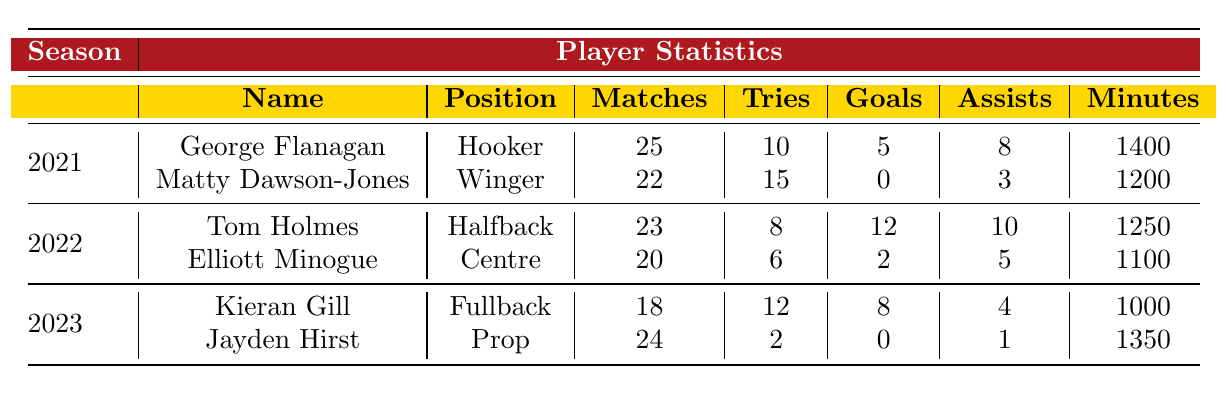What is the total number of tries scored by George Flanagan in the 2021 season? George Flanagan scored 10 tries in the 2021 season, as indicated in the table under his player's statistics.
Answer: 10 How many goals did Matty Dawson-Jones score in the 2021 season? The table shows that Matty Dawson-Jones scored 0 goals during the 2021 season.
Answer: 0 In which season did Tom Holmes have the highest number of assists? The table indicates that Tom Holmes recorded 10 assists in the 2022 season, which is higher than the assists of other players listed.
Answer: 2022 What is the average number of matches played by players in the 2023 season? Kieran Gill played 18 matches and Jayden Hirst played 24 matches in 2023. The average is calculated as (18 + 24) / 2 = 21.
Answer: 21 Which player played the most minutes in the 2021 season? Based on the table, George Flanagan played 1400 minutes, which is more than Matty Dawson-Jones's 1200 minutes, making him the player with the most minutes in 2021.
Answer: George Flanagan Did Elliott Minogue score more tries than Kieran Gill in their respective seasons? Elliott Minogue scored 6 tries in 2022 while Kieran Gill scored 12 tries in 2023. Since 12 is greater than 6, Kieran Gill scored more tries than Elliott Minogue.
Answer: No What is the total number of goals scored by players in the 2022 season? In 2022, Tom Holmes scored 12 goals, and Elliott Minogue scored 2 goals. The total is 12 + 2 = 14 goals.
Answer: 14 Which position had the highest number of players in the dataset? The dataset contains only one player per position for each season. Therefore, there is no position with more than one player listed.
Answer: No position had more players What was the difference in minutes played between Kieran Gill and Matty Dawson-Jones? Kieran Gill played 1000 minutes in 2023, while Matty Dawson-Jones played 1200 minutes in 2021. The difference is 1200 - 1000 = 200 minutes.
Answer: 200 minutes What is the total number of matches played by all players in the 2022 season? Tom Holmes played 23 matches and Elliott Minogue played 20 matches in 2022. The total is 23 + 20 = 43 matches played in 2022.
Answer: 43 